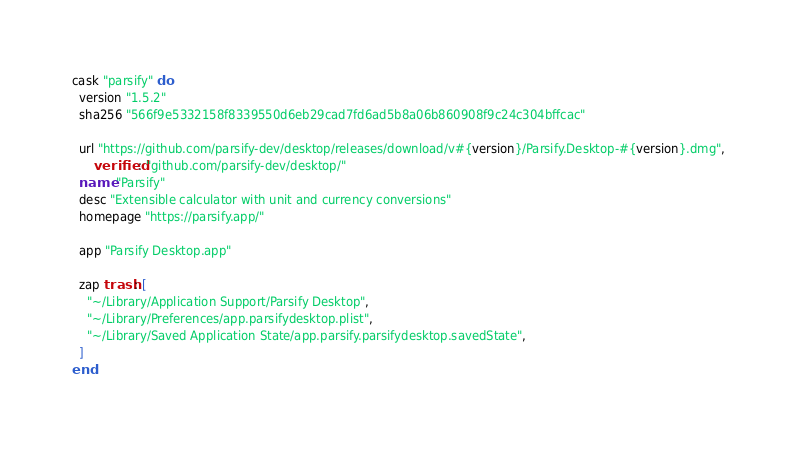<code> <loc_0><loc_0><loc_500><loc_500><_Ruby_>cask "parsify" do
  version "1.5.2"
  sha256 "566f9e5332158f8339550d6eb29cad7fd6ad5b8a06b860908f9c24c304bffcac"

  url "https://github.com/parsify-dev/desktop/releases/download/v#{version}/Parsify.Desktop-#{version}.dmg",
      verified: "github.com/parsify-dev/desktop/"
  name "Parsify"
  desc "Extensible calculator with unit and currency conversions"
  homepage "https://parsify.app/"

  app "Parsify Desktop.app"

  zap trash: [
    "~/Library/Application Support/Parsify Desktop",
    "~/Library/Preferences/app.parsifydesktop.plist",
    "~/Library/Saved Application State/app.parsify.parsifydesktop.savedState",
  ]
end
</code> 